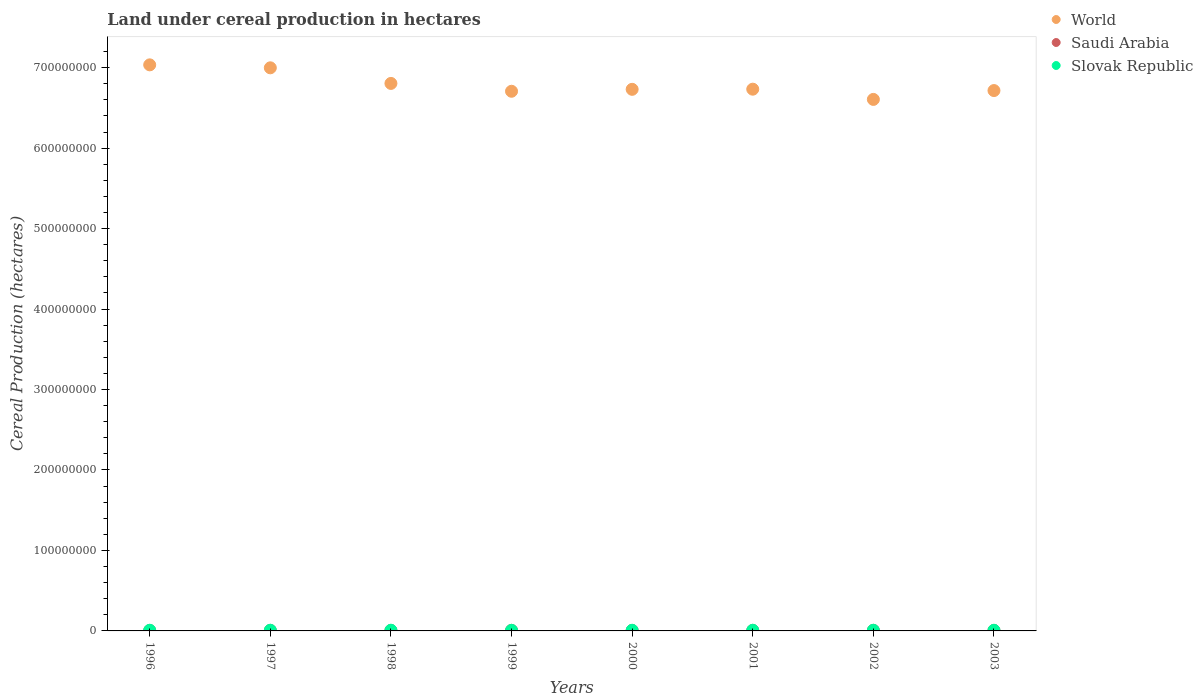Is the number of dotlines equal to the number of legend labels?
Ensure brevity in your answer.  Yes. What is the land under cereal production in World in 2003?
Give a very brief answer. 6.72e+08. Across all years, what is the maximum land under cereal production in Saudi Arabia?
Ensure brevity in your answer.  7.05e+05. Across all years, what is the minimum land under cereal production in Slovak Republic?
Your response must be concise. 7.34e+05. In which year was the land under cereal production in Slovak Republic minimum?
Provide a short and direct response. 1999. What is the total land under cereal production in Slovak Republic in the graph?
Make the answer very short. 6.54e+06. What is the difference between the land under cereal production in World in 2000 and that in 2003?
Offer a terse response. 1.53e+06. What is the difference between the land under cereal production in World in 2003 and the land under cereal production in Saudi Arabia in 1999?
Your answer should be very brief. 6.71e+08. What is the average land under cereal production in Saudi Arabia per year?
Provide a succinct answer. 6.51e+05. In the year 2001, what is the difference between the land under cereal production in World and land under cereal production in Slovak Republic?
Offer a very short reply. 6.72e+08. What is the ratio of the land under cereal production in Slovak Republic in 1996 to that in 1999?
Your response must be concise. 1.13. Is the land under cereal production in Slovak Republic in 1997 less than that in 2003?
Offer a terse response. No. Is the difference between the land under cereal production in World in 1998 and 2002 greater than the difference between the land under cereal production in Slovak Republic in 1998 and 2002?
Provide a short and direct response. Yes. What is the difference between the highest and the second highest land under cereal production in Saudi Arabia?
Provide a short and direct response. 7498. What is the difference between the highest and the lowest land under cereal production in Saudi Arabia?
Keep it short and to the point. 1.42e+05. In how many years, is the land under cereal production in Saudi Arabia greater than the average land under cereal production in Saudi Arabia taken over all years?
Provide a succinct answer. 5. Is the sum of the land under cereal production in Saudi Arabia in 1996 and 2000 greater than the maximum land under cereal production in World across all years?
Provide a succinct answer. No. Does the land under cereal production in Saudi Arabia monotonically increase over the years?
Provide a succinct answer. No. How many dotlines are there?
Your answer should be very brief. 3. How many years are there in the graph?
Ensure brevity in your answer.  8. What is the difference between two consecutive major ticks on the Y-axis?
Your answer should be very brief. 1.00e+08. Are the values on the major ticks of Y-axis written in scientific E-notation?
Give a very brief answer. No. Does the graph contain grids?
Offer a very short reply. No. How many legend labels are there?
Give a very brief answer. 3. What is the title of the graph?
Your answer should be very brief. Land under cereal production in hectares. Does "Peru" appear as one of the legend labels in the graph?
Offer a terse response. No. What is the label or title of the Y-axis?
Make the answer very short. Cereal Production (hectares). What is the Cereal Production (hectares) in World in 1996?
Provide a short and direct response. 7.03e+08. What is the Cereal Production (hectares) in Saudi Arabia in 1996?
Your response must be concise. 5.63e+05. What is the Cereal Production (hectares) in Slovak Republic in 1996?
Ensure brevity in your answer.  8.28e+05. What is the Cereal Production (hectares) of World in 1997?
Your answer should be compact. 7.00e+08. What is the Cereal Production (hectares) of Saudi Arabia in 1997?
Offer a terse response. 6.56e+05. What is the Cereal Production (hectares) of Slovak Republic in 1997?
Give a very brief answer. 8.50e+05. What is the Cereal Production (hectares) of World in 1998?
Ensure brevity in your answer.  6.80e+08. What is the Cereal Production (hectares) of Saudi Arabia in 1998?
Give a very brief answer. 6.22e+05. What is the Cereal Production (hectares) of Slovak Republic in 1998?
Keep it short and to the point. 8.60e+05. What is the Cereal Production (hectares) in World in 1999?
Provide a succinct answer. 6.71e+08. What is the Cereal Production (hectares) of Saudi Arabia in 1999?
Your answer should be compact. 6.86e+05. What is the Cereal Production (hectares) of Slovak Republic in 1999?
Your response must be concise. 7.34e+05. What is the Cereal Production (hectares) of World in 2000?
Provide a short and direct response. 6.73e+08. What is the Cereal Production (hectares) of Saudi Arabia in 2000?
Give a very brief answer. 6.16e+05. What is the Cereal Production (hectares) in Slovak Republic in 2000?
Your response must be concise. 8.13e+05. What is the Cereal Production (hectares) of World in 2001?
Your answer should be very brief. 6.73e+08. What is the Cereal Production (hectares) of Saudi Arabia in 2001?
Make the answer very short. 6.59e+05. What is the Cereal Production (hectares) in Slovak Republic in 2001?
Offer a very short reply. 8.35e+05. What is the Cereal Production (hectares) of World in 2002?
Give a very brief answer. 6.61e+08. What is the Cereal Production (hectares) in Saudi Arabia in 2002?
Make the answer very short. 7.05e+05. What is the Cereal Production (hectares) in Slovak Republic in 2002?
Provide a short and direct response. 8.20e+05. What is the Cereal Production (hectares) of World in 2003?
Your response must be concise. 6.72e+08. What is the Cereal Production (hectares) in Saudi Arabia in 2003?
Your answer should be compact. 6.97e+05. What is the Cereal Production (hectares) in Slovak Republic in 2003?
Your answer should be very brief. 7.95e+05. Across all years, what is the maximum Cereal Production (hectares) in World?
Offer a very short reply. 7.03e+08. Across all years, what is the maximum Cereal Production (hectares) in Saudi Arabia?
Offer a terse response. 7.05e+05. Across all years, what is the maximum Cereal Production (hectares) of Slovak Republic?
Ensure brevity in your answer.  8.60e+05. Across all years, what is the minimum Cereal Production (hectares) of World?
Your response must be concise. 6.61e+08. Across all years, what is the minimum Cereal Production (hectares) of Saudi Arabia?
Provide a succinct answer. 5.63e+05. Across all years, what is the minimum Cereal Production (hectares) of Slovak Republic?
Your answer should be very brief. 7.34e+05. What is the total Cereal Production (hectares) in World in the graph?
Your answer should be very brief. 5.43e+09. What is the total Cereal Production (hectares) of Saudi Arabia in the graph?
Provide a succinct answer. 5.21e+06. What is the total Cereal Production (hectares) in Slovak Republic in the graph?
Make the answer very short. 6.54e+06. What is the difference between the Cereal Production (hectares) in World in 1996 and that in 1997?
Provide a succinct answer. 3.68e+06. What is the difference between the Cereal Production (hectares) of Saudi Arabia in 1996 and that in 1997?
Ensure brevity in your answer.  -9.32e+04. What is the difference between the Cereal Production (hectares) in Slovak Republic in 1996 and that in 1997?
Give a very brief answer. -2.26e+04. What is the difference between the Cereal Production (hectares) in World in 1996 and that in 1998?
Give a very brief answer. 2.31e+07. What is the difference between the Cereal Production (hectares) of Saudi Arabia in 1996 and that in 1998?
Give a very brief answer. -5.86e+04. What is the difference between the Cereal Production (hectares) of Slovak Republic in 1996 and that in 1998?
Ensure brevity in your answer.  -3.20e+04. What is the difference between the Cereal Production (hectares) in World in 1996 and that in 1999?
Offer a terse response. 3.28e+07. What is the difference between the Cereal Production (hectares) of Saudi Arabia in 1996 and that in 1999?
Your response must be concise. -1.23e+05. What is the difference between the Cereal Production (hectares) of Slovak Republic in 1996 and that in 1999?
Offer a terse response. 9.40e+04. What is the difference between the Cereal Production (hectares) in World in 1996 and that in 2000?
Keep it short and to the point. 3.04e+07. What is the difference between the Cereal Production (hectares) in Saudi Arabia in 1996 and that in 2000?
Give a very brief answer. -5.32e+04. What is the difference between the Cereal Production (hectares) of Slovak Republic in 1996 and that in 2000?
Give a very brief answer. 1.44e+04. What is the difference between the Cereal Production (hectares) in World in 1996 and that in 2001?
Provide a succinct answer. 3.02e+07. What is the difference between the Cereal Production (hectares) in Saudi Arabia in 1996 and that in 2001?
Provide a succinct answer. -9.59e+04. What is the difference between the Cereal Production (hectares) in Slovak Republic in 1996 and that in 2001?
Provide a succinct answer. -7431. What is the difference between the Cereal Production (hectares) of World in 1996 and that in 2002?
Offer a terse response. 4.29e+07. What is the difference between the Cereal Production (hectares) in Saudi Arabia in 1996 and that in 2002?
Your answer should be compact. -1.42e+05. What is the difference between the Cereal Production (hectares) in Slovak Republic in 1996 and that in 2002?
Your answer should be compact. 7393. What is the difference between the Cereal Production (hectares) in World in 1996 and that in 2003?
Your response must be concise. 3.19e+07. What is the difference between the Cereal Production (hectares) in Saudi Arabia in 1996 and that in 2003?
Give a very brief answer. -1.34e+05. What is the difference between the Cereal Production (hectares) in Slovak Republic in 1996 and that in 2003?
Keep it short and to the point. 3.33e+04. What is the difference between the Cereal Production (hectares) of World in 1997 and that in 1998?
Provide a succinct answer. 1.94e+07. What is the difference between the Cereal Production (hectares) in Saudi Arabia in 1997 and that in 1998?
Offer a terse response. 3.46e+04. What is the difference between the Cereal Production (hectares) of Slovak Republic in 1997 and that in 1998?
Make the answer very short. -9363. What is the difference between the Cereal Production (hectares) of World in 1997 and that in 1999?
Your answer should be compact. 2.91e+07. What is the difference between the Cereal Production (hectares) of Saudi Arabia in 1997 and that in 1999?
Your answer should be very brief. -3.00e+04. What is the difference between the Cereal Production (hectares) of Slovak Republic in 1997 and that in 1999?
Offer a very short reply. 1.17e+05. What is the difference between the Cereal Production (hectares) of World in 1997 and that in 2000?
Provide a succinct answer. 2.67e+07. What is the difference between the Cereal Production (hectares) of Saudi Arabia in 1997 and that in 2000?
Offer a very short reply. 4.00e+04. What is the difference between the Cereal Production (hectares) in Slovak Republic in 1997 and that in 2000?
Your answer should be very brief. 3.70e+04. What is the difference between the Cereal Production (hectares) of World in 1997 and that in 2001?
Your answer should be compact. 2.66e+07. What is the difference between the Cereal Production (hectares) of Saudi Arabia in 1997 and that in 2001?
Your response must be concise. -2737. What is the difference between the Cereal Production (hectares) in Slovak Republic in 1997 and that in 2001?
Your answer should be compact. 1.52e+04. What is the difference between the Cereal Production (hectares) of World in 1997 and that in 2002?
Give a very brief answer. 3.93e+07. What is the difference between the Cereal Production (hectares) in Saudi Arabia in 1997 and that in 2002?
Your response must be concise. -4.84e+04. What is the difference between the Cereal Production (hectares) of Slovak Republic in 1997 and that in 2002?
Offer a very short reply. 3.00e+04. What is the difference between the Cereal Production (hectares) of World in 1997 and that in 2003?
Your answer should be very brief. 2.83e+07. What is the difference between the Cereal Production (hectares) of Saudi Arabia in 1997 and that in 2003?
Give a very brief answer. -4.09e+04. What is the difference between the Cereal Production (hectares) in Slovak Republic in 1997 and that in 2003?
Make the answer very short. 5.59e+04. What is the difference between the Cereal Production (hectares) in World in 1998 and that in 1999?
Your answer should be very brief. 9.75e+06. What is the difference between the Cereal Production (hectares) of Saudi Arabia in 1998 and that in 1999?
Your answer should be compact. -6.45e+04. What is the difference between the Cereal Production (hectares) of Slovak Republic in 1998 and that in 1999?
Keep it short and to the point. 1.26e+05. What is the difference between the Cereal Production (hectares) in World in 1998 and that in 2000?
Offer a very short reply. 7.34e+06. What is the difference between the Cereal Production (hectares) of Saudi Arabia in 1998 and that in 2000?
Your answer should be very brief. 5457. What is the difference between the Cereal Production (hectares) of Slovak Republic in 1998 and that in 2000?
Ensure brevity in your answer.  4.64e+04. What is the difference between the Cereal Production (hectares) of World in 1998 and that in 2001?
Make the answer very short. 7.16e+06. What is the difference between the Cereal Production (hectares) in Saudi Arabia in 1998 and that in 2001?
Provide a short and direct response. -3.73e+04. What is the difference between the Cereal Production (hectares) in Slovak Republic in 1998 and that in 2001?
Keep it short and to the point. 2.46e+04. What is the difference between the Cereal Production (hectares) in World in 1998 and that in 2002?
Provide a short and direct response. 1.99e+07. What is the difference between the Cereal Production (hectares) of Saudi Arabia in 1998 and that in 2002?
Offer a very short reply. -8.30e+04. What is the difference between the Cereal Production (hectares) of Slovak Republic in 1998 and that in 2002?
Keep it short and to the point. 3.94e+04. What is the difference between the Cereal Production (hectares) in World in 1998 and that in 2003?
Ensure brevity in your answer.  8.87e+06. What is the difference between the Cereal Production (hectares) in Saudi Arabia in 1998 and that in 2003?
Ensure brevity in your answer.  -7.55e+04. What is the difference between the Cereal Production (hectares) of Slovak Republic in 1998 and that in 2003?
Ensure brevity in your answer.  6.53e+04. What is the difference between the Cereal Production (hectares) in World in 1999 and that in 2000?
Give a very brief answer. -2.40e+06. What is the difference between the Cereal Production (hectares) of Saudi Arabia in 1999 and that in 2000?
Provide a short and direct response. 7.00e+04. What is the difference between the Cereal Production (hectares) in Slovak Republic in 1999 and that in 2000?
Make the answer very short. -7.96e+04. What is the difference between the Cereal Production (hectares) of World in 1999 and that in 2001?
Make the answer very short. -2.59e+06. What is the difference between the Cereal Production (hectares) in Saudi Arabia in 1999 and that in 2001?
Your response must be concise. 2.73e+04. What is the difference between the Cereal Production (hectares) in Slovak Republic in 1999 and that in 2001?
Offer a very short reply. -1.01e+05. What is the difference between the Cereal Production (hectares) of World in 1999 and that in 2002?
Offer a very short reply. 1.01e+07. What is the difference between the Cereal Production (hectares) in Saudi Arabia in 1999 and that in 2002?
Give a very brief answer. -1.84e+04. What is the difference between the Cereal Production (hectares) of Slovak Republic in 1999 and that in 2002?
Provide a succinct answer. -8.66e+04. What is the difference between the Cereal Production (hectares) in World in 1999 and that in 2003?
Ensure brevity in your answer.  -8.71e+05. What is the difference between the Cereal Production (hectares) of Saudi Arabia in 1999 and that in 2003?
Your response must be concise. -1.09e+04. What is the difference between the Cereal Production (hectares) in Slovak Republic in 1999 and that in 2003?
Offer a very short reply. -6.07e+04. What is the difference between the Cereal Production (hectares) in World in 2000 and that in 2001?
Give a very brief answer. -1.80e+05. What is the difference between the Cereal Production (hectares) of Saudi Arabia in 2000 and that in 2001?
Offer a terse response. -4.27e+04. What is the difference between the Cereal Production (hectares) in Slovak Republic in 2000 and that in 2001?
Provide a succinct answer. -2.18e+04. What is the difference between the Cereal Production (hectares) of World in 2000 and that in 2002?
Your answer should be compact. 1.25e+07. What is the difference between the Cereal Production (hectares) in Saudi Arabia in 2000 and that in 2002?
Keep it short and to the point. -8.84e+04. What is the difference between the Cereal Production (hectares) in Slovak Republic in 2000 and that in 2002?
Keep it short and to the point. -6992. What is the difference between the Cereal Production (hectares) in World in 2000 and that in 2003?
Give a very brief answer. 1.53e+06. What is the difference between the Cereal Production (hectares) of Saudi Arabia in 2000 and that in 2003?
Your answer should be compact. -8.09e+04. What is the difference between the Cereal Production (hectares) in Slovak Republic in 2000 and that in 2003?
Provide a succinct answer. 1.89e+04. What is the difference between the Cereal Production (hectares) of World in 2001 and that in 2002?
Your answer should be very brief. 1.27e+07. What is the difference between the Cereal Production (hectares) in Saudi Arabia in 2001 and that in 2002?
Offer a very short reply. -4.57e+04. What is the difference between the Cereal Production (hectares) in Slovak Republic in 2001 and that in 2002?
Provide a short and direct response. 1.48e+04. What is the difference between the Cereal Production (hectares) of World in 2001 and that in 2003?
Your answer should be very brief. 1.71e+06. What is the difference between the Cereal Production (hectares) of Saudi Arabia in 2001 and that in 2003?
Offer a very short reply. -3.82e+04. What is the difference between the Cereal Production (hectares) in Slovak Republic in 2001 and that in 2003?
Make the answer very short. 4.07e+04. What is the difference between the Cereal Production (hectares) of World in 2002 and that in 2003?
Your response must be concise. -1.10e+07. What is the difference between the Cereal Production (hectares) in Saudi Arabia in 2002 and that in 2003?
Your answer should be compact. 7498. What is the difference between the Cereal Production (hectares) in Slovak Republic in 2002 and that in 2003?
Make the answer very short. 2.59e+04. What is the difference between the Cereal Production (hectares) in World in 1996 and the Cereal Production (hectares) in Saudi Arabia in 1997?
Ensure brevity in your answer.  7.03e+08. What is the difference between the Cereal Production (hectares) in World in 1996 and the Cereal Production (hectares) in Slovak Republic in 1997?
Give a very brief answer. 7.03e+08. What is the difference between the Cereal Production (hectares) of Saudi Arabia in 1996 and the Cereal Production (hectares) of Slovak Republic in 1997?
Provide a short and direct response. -2.87e+05. What is the difference between the Cereal Production (hectares) in World in 1996 and the Cereal Production (hectares) in Saudi Arabia in 1998?
Ensure brevity in your answer.  7.03e+08. What is the difference between the Cereal Production (hectares) in World in 1996 and the Cereal Production (hectares) in Slovak Republic in 1998?
Give a very brief answer. 7.03e+08. What is the difference between the Cereal Production (hectares) in Saudi Arabia in 1996 and the Cereal Production (hectares) in Slovak Republic in 1998?
Your answer should be very brief. -2.97e+05. What is the difference between the Cereal Production (hectares) of World in 1996 and the Cereal Production (hectares) of Saudi Arabia in 1999?
Your answer should be compact. 7.03e+08. What is the difference between the Cereal Production (hectares) of World in 1996 and the Cereal Production (hectares) of Slovak Republic in 1999?
Make the answer very short. 7.03e+08. What is the difference between the Cereal Production (hectares) of Saudi Arabia in 1996 and the Cereal Production (hectares) of Slovak Republic in 1999?
Your answer should be very brief. -1.71e+05. What is the difference between the Cereal Production (hectares) in World in 1996 and the Cereal Production (hectares) in Saudi Arabia in 2000?
Give a very brief answer. 7.03e+08. What is the difference between the Cereal Production (hectares) in World in 1996 and the Cereal Production (hectares) in Slovak Republic in 2000?
Make the answer very short. 7.03e+08. What is the difference between the Cereal Production (hectares) of Saudi Arabia in 1996 and the Cereal Production (hectares) of Slovak Republic in 2000?
Make the answer very short. -2.50e+05. What is the difference between the Cereal Production (hectares) in World in 1996 and the Cereal Production (hectares) in Saudi Arabia in 2001?
Offer a very short reply. 7.03e+08. What is the difference between the Cereal Production (hectares) in World in 1996 and the Cereal Production (hectares) in Slovak Republic in 2001?
Your answer should be compact. 7.03e+08. What is the difference between the Cereal Production (hectares) in Saudi Arabia in 1996 and the Cereal Production (hectares) in Slovak Republic in 2001?
Your response must be concise. -2.72e+05. What is the difference between the Cereal Production (hectares) in World in 1996 and the Cereal Production (hectares) in Saudi Arabia in 2002?
Make the answer very short. 7.03e+08. What is the difference between the Cereal Production (hectares) in World in 1996 and the Cereal Production (hectares) in Slovak Republic in 2002?
Provide a short and direct response. 7.03e+08. What is the difference between the Cereal Production (hectares) of Saudi Arabia in 1996 and the Cereal Production (hectares) of Slovak Republic in 2002?
Your response must be concise. -2.57e+05. What is the difference between the Cereal Production (hectares) of World in 1996 and the Cereal Production (hectares) of Saudi Arabia in 2003?
Provide a succinct answer. 7.03e+08. What is the difference between the Cereal Production (hectares) of World in 1996 and the Cereal Production (hectares) of Slovak Republic in 2003?
Your response must be concise. 7.03e+08. What is the difference between the Cereal Production (hectares) in Saudi Arabia in 1996 and the Cereal Production (hectares) in Slovak Republic in 2003?
Offer a terse response. -2.31e+05. What is the difference between the Cereal Production (hectares) in World in 1997 and the Cereal Production (hectares) in Saudi Arabia in 1998?
Your answer should be very brief. 6.99e+08. What is the difference between the Cereal Production (hectares) of World in 1997 and the Cereal Production (hectares) of Slovak Republic in 1998?
Offer a very short reply. 6.99e+08. What is the difference between the Cereal Production (hectares) of Saudi Arabia in 1997 and the Cereal Production (hectares) of Slovak Republic in 1998?
Provide a short and direct response. -2.03e+05. What is the difference between the Cereal Production (hectares) of World in 1997 and the Cereal Production (hectares) of Saudi Arabia in 1999?
Give a very brief answer. 6.99e+08. What is the difference between the Cereal Production (hectares) of World in 1997 and the Cereal Production (hectares) of Slovak Republic in 1999?
Give a very brief answer. 6.99e+08. What is the difference between the Cereal Production (hectares) of Saudi Arabia in 1997 and the Cereal Production (hectares) of Slovak Republic in 1999?
Offer a very short reply. -7.75e+04. What is the difference between the Cereal Production (hectares) of World in 1997 and the Cereal Production (hectares) of Saudi Arabia in 2000?
Ensure brevity in your answer.  6.99e+08. What is the difference between the Cereal Production (hectares) in World in 1997 and the Cereal Production (hectares) in Slovak Republic in 2000?
Your answer should be compact. 6.99e+08. What is the difference between the Cereal Production (hectares) of Saudi Arabia in 1997 and the Cereal Production (hectares) of Slovak Republic in 2000?
Give a very brief answer. -1.57e+05. What is the difference between the Cereal Production (hectares) of World in 1997 and the Cereal Production (hectares) of Saudi Arabia in 2001?
Offer a terse response. 6.99e+08. What is the difference between the Cereal Production (hectares) in World in 1997 and the Cereal Production (hectares) in Slovak Republic in 2001?
Your response must be concise. 6.99e+08. What is the difference between the Cereal Production (hectares) in Saudi Arabia in 1997 and the Cereal Production (hectares) in Slovak Republic in 2001?
Offer a terse response. -1.79e+05. What is the difference between the Cereal Production (hectares) of World in 1997 and the Cereal Production (hectares) of Saudi Arabia in 2002?
Make the answer very short. 6.99e+08. What is the difference between the Cereal Production (hectares) of World in 1997 and the Cereal Production (hectares) of Slovak Republic in 2002?
Provide a succinct answer. 6.99e+08. What is the difference between the Cereal Production (hectares) in Saudi Arabia in 1997 and the Cereal Production (hectares) in Slovak Republic in 2002?
Your response must be concise. -1.64e+05. What is the difference between the Cereal Production (hectares) of World in 1997 and the Cereal Production (hectares) of Saudi Arabia in 2003?
Offer a very short reply. 6.99e+08. What is the difference between the Cereal Production (hectares) of World in 1997 and the Cereal Production (hectares) of Slovak Republic in 2003?
Give a very brief answer. 6.99e+08. What is the difference between the Cereal Production (hectares) of Saudi Arabia in 1997 and the Cereal Production (hectares) of Slovak Republic in 2003?
Your response must be concise. -1.38e+05. What is the difference between the Cereal Production (hectares) of World in 1998 and the Cereal Production (hectares) of Saudi Arabia in 1999?
Ensure brevity in your answer.  6.80e+08. What is the difference between the Cereal Production (hectares) of World in 1998 and the Cereal Production (hectares) of Slovak Republic in 1999?
Ensure brevity in your answer.  6.80e+08. What is the difference between the Cereal Production (hectares) of Saudi Arabia in 1998 and the Cereal Production (hectares) of Slovak Republic in 1999?
Ensure brevity in your answer.  -1.12e+05. What is the difference between the Cereal Production (hectares) of World in 1998 and the Cereal Production (hectares) of Saudi Arabia in 2000?
Your answer should be very brief. 6.80e+08. What is the difference between the Cereal Production (hectares) in World in 1998 and the Cereal Production (hectares) in Slovak Republic in 2000?
Provide a short and direct response. 6.80e+08. What is the difference between the Cereal Production (hectares) in Saudi Arabia in 1998 and the Cereal Production (hectares) in Slovak Republic in 2000?
Your answer should be very brief. -1.92e+05. What is the difference between the Cereal Production (hectares) in World in 1998 and the Cereal Production (hectares) in Saudi Arabia in 2001?
Provide a succinct answer. 6.80e+08. What is the difference between the Cereal Production (hectares) in World in 1998 and the Cereal Production (hectares) in Slovak Republic in 2001?
Your response must be concise. 6.80e+08. What is the difference between the Cereal Production (hectares) of Saudi Arabia in 1998 and the Cereal Production (hectares) of Slovak Republic in 2001?
Provide a short and direct response. -2.13e+05. What is the difference between the Cereal Production (hectares) in World in 1998 and the Cereal Production (hectares) in Saudi Arabia in 2002?
Your answer should be very brief. 6.80e+08. What is the difference between the Cereal Production (hectares) in World in 1998 and the Cereal Production (hectares) in Slovak Republic in 2002?
Make the answer very short. 6.80e+08. What is the difference between the Cereal Production (hectares) of Saudi Arabia in 1998 and the Cereal Production (hectares) of Slovak Republic in 2002?
Offer a very short reply. -1.99e+05. What is the difference between the Cereal Production (hectares) in World in 1998 and the Cereal Production (hectares) in Saudi Arabia in 2003?
Provide a short and direct response. 6.80e+08. What is the difference between the Cereal Production (hectares) of World in 1998 and the Cereal Production (hectares) of Slovak Republic in 2003?
Offer a very short reply. 6.80e+08. What is the difference between the Cereal Production (hectares) of Saudi Arabia in 1998 and the Cereal Production (hectares) of Slovak Republic in 2003?
Give a very brief answer. -1.73e+05. What is the difference between the Cereal Production (hectares) of World in 1999 and the Cereal Production (hectares) of Saudi Arabia in 2000?
Your answer should be very brief. 6.70e+08. What is the difference between the Cereal Production (hectares) of World in 1999 and the Cereal Production (hectares) of Slovak Republic in 2000?
Give a very brief answer. 6.70e+08. What is the difference between the Cereal Production (hectares) of Saudi Arabia in 1999 and the Cereal Production (hectares) of Slovak Republic in 2000?
Offer a terse response. -1.27e+05. What is the difference between the Cereal Production (hectares) in World in 1999 and the Cereal Production (hectares) in Saudi Arabia in 2001?
Provide a succinct answer. 6.70e+08. What is the difference between the Cereal Production (hectares) in World in 1999 and the Cereal Production (hectares) in Slovak Republic in 2001?
Offer a terse response. 6.70e+08. What is the difference between the Cereal Production (hectares) of Saudi Arabia in 1999 and the Cereal Production (hectares) of Slovak Republic in 2001?
Provide a succinct answer. -1.49e+05. What is the difference between the Cereal Production (hectares) in World in 1999 and the Cereal Production (hectares) in Saudi Arabia in 2002?
Provide a succinct answer. 6.70e+08. What is the difference between the Cereal Production (hectares) of World in 1999 and the Cereal Production (hectares) of Slovak Republic in 2002?
Ensure brevity in your answer.  6.70e+08. What is the difference between the Cereal Production (hectares) in Saudi Arabia in 1999 and the Cereal Production (hectares) in Slovak Republic in 2002?
Your answer should be very brief. -1.34e+05. What is the difference between the Cereal Production (hectares) of World in 1999 and the Cereal Production (hectares) of Saudi Arabia in 2003?
Give a very brief answer. 6.70e+08. What is the difference between the Cereal Production (hectares) in World in 1999 and the Cereal Production (hectares) in Slovak Republic in 2003?
Offer a very short reply. 6.70e+08. What is the difference between the Cereal Production (hectares) in Saudi Arabia in 1999 and the Cereal Production (hectares) in Slovak Republic in 2003?
Give a very brief answer. -1.08e+05. What is the difference between the Cereal Production (hectares) of World in 2000 and the Cereal Production (hectares) of Saudi Arabia in 2001?
Provide a short and direct response. 6.72e+08. What is the difference between the Cereal Production (hectares) in World in 2000 and the Cereal Production (hectares) in Slovak Republic in 2001?
Your answer should be very brief. 6.72e+08. What is the difference between the Cereal Production (hectares) of Saudi Arabia in 2000 and the Cereal Production (hectares) of Slovak Republic in 2001?
Offer a terse response. -2.19e+05. What is the difference between the Cereal Production (hectares) of World in 2000 and the Cereal Production (hectares) of Saudi Arabia in 2002?
Keep it short and to the point. 6.72e+08. What is the difference between the Cereal Production (hectares) in World in 2000 and the Cereal Production (hectares) in Slovak Republic in 2002?
Provide a succinct answer. 6.72e+08. What is the difference between the Cereal Production (hectares) in Saudi Arabia in 2000 and the Cereal Production (hectares) in Slovak Republic in 2002?
Offer a terse response. -2.04e+05. What is the difference between the Cereal Production (hectares) of World in 2000 and the Cereal Production (hectares) of Saudi Arabia in 2003?
Make the answer very short. 6.72e+08. What is the difference between the Cereal Production (hectares) in World in 2000 and the Cereal Production (hectares) in Slovak Republic in 2003?
Your response must be concise. 6.72e+08. What is the difference between the Cereal Production (hectares) in Saudi Arabia in 2000 and the Cereal Production (hectares) in Slovak Republic in 2003?
Keep it short and to the point. -1.78e+05. What is the difference between the Cereal Production (hectares) of World in 2001 and the Cereal Production (hectares) of Saudi Arabia in 2002?
Make the answer very short. 6.73e+08. What is the difference between the Cereal Production (hectares) in World in 2001 and the Cereal Production (hectares) in Slovak Republic in 2002?
Provide a succinct answer. 6.72e+08. What is the difference between the Cereal Production (hectares) in Saudi Arabia in 2001 and the Cereal Production (hectares) in Slovak Republic in 2002?
Your answer should be very brief. -1.61e+05. What is the difference between the Cereal Production (hectares) in World in 2001 and the Cereal Production (hectares) in Saudi Arabia in 2003?
Provide a succinct answer. 6.73e+08. What is the difference between the Cereal Production (hectares) of World in 2001 and the Cereal Production (hectares) of Slovak Republic in 2003?
Ensure brevity in your answer.  6.72e+08. What is the difference between the Cereal Production (hectares) in Saudi Arabia in 2001 and the Cereal Production (hectares) in Slovak Republic in 2003?
Your answer should be compact. -1.35e+05. What is the difference between the Cereal Production (hectares) in World in 2002 and the Cereal Production (hectares) in Saudi Arabia in 2003?
Your answer should be compact. 6.60e+08. What is the difference between the Cereal Production (hectares) of World in 2002 and the Cereal Production (hectares) of Slovak Republic in 2003?
Make the answer very short. 6.60e+08. What is the difference between the Cereal Production (hectares) of Saudi Arabia in 2002 and the Cereal Production (hectares) of Slovak Republic in 2003?
Your response must be concise. -8.97e+04. What is the average Cereal Production (hectares) of World per year?
Offer a very short reply. 6.79e+08. What is the average Cereal Production (hectares) of Saudi Arabia per year?
Your response must be concise. 6.51e+05. What is the average Cereal Production (hectares) of Slovak Republic per year?
Offer a terse response. 8.17e+05. In the year 1996, what is the difference between the Cereal Production (hectares) in World and Cereal Production (hectares) in Saudi Arabia?
Ensure brevity in your answer.  7.03e+08. In the year 1996, what is the difference between the Cereal Production (hectares) of World and Cereal Production (hectares) of Slovak Republic?
Your answer should be compact. 7.03e+08. In the year 1996, what is the difference between the Cereal Production (hectares) of Saudi Arabia and Cereal Production (hectares) of Slovak Republic?
Your answer should be compact. -2.65e+05. In the year 1997, what is the difference between the Cereal Production (hectares) of World and Cereal Production (hectares) of Saudi Arabia?
Provide a short and direct response. 6.99e+08. In the year 1997, what is the difference between the Cereal Production (hectares) in World and Cereal Production (hectares) in Slovak Republic?
Ensure brevity in your answer.  6.99e+08. In the year 1997, what is the difference between the Cereal Production (hectares) in Saudi Arabia and Cereal Production (hectares) in Slovak Republic?
Provide a succinct answer. -1.94e+05. In the year 1998, what is the difference between the Cereal Production (hectares) in World and Cereal Production (hectares) in Saudi Arabia?
Your response must be concise. 6.80e+08. In the year 1998, what is the difference between the Cereal Production (hectares) of World and Cereal Production (hectares) of Slovak Republic?
Offer a very short reply. 6.80e+08. In the year 1998, what is the difference between the Cereal Production (hectares) in Saudi Arabia and Cereal Production (hectares) in Slovak Republic?
Offer a terse response. -2.38e+05. In the year 1999, what is the difference between the Cereal Production (hectares) in World and Cereal Production (hectares) in Saudi Arabia?
Your answer should be compact. 6.70e+08. In the year 1999, what is the difference between the Cereal Production (hectares) of World and Cereal Production (hectares) of Slovak Republic?
Provide a succinct answer. 6.70e+08. In the year 1999, what is the difference between the Cereal Production (hectares) of Saudi Arabia and Cereal Production (hectares) of Slovak Republic?
Offer a very short reply. -4.75e+04. In the year 2000, what is the difference between the Cereal Production (hectares) of World and Cereal Production (hectares) of Saudi Arabia?
Your response must be concise. 6.72e+08. In the year 2000, what is the difference between the Cereal Production (hectares) in World and Cereal Production (hectares) in Slovak Republic?
Keep it short and to the point. 6.72e+08. In the year 2000, what is the difference between the Cereal Production (hectares) of Saudi Arabia and Cereal Production (hectares) of Slovak Republic?
Ensure brevity in your answer.  -1.97e+05. In the year 2001, what is the difference between the Cereal Production (hectares) in World and Cereal Production (hectares) in Saudi Arabia?
Ensure brevity in your answer.  6.73e+08. In the year 2001, what is the difference between the Cereal Production (hectares) in World and Cereal Production (hectares) in Slovak Republic?
Your answer should be compact. 6.72e+08. In the year 2001, what is the difference between the Cereal Production (hectares) in Saudi Arabia and Cereal Production (hectares) in Slovak Republic?
Your response must be concise. -1.76e+05. In the year 2002, what is the difference between the Cereal Production (hectares) in World and Cereal Production (hectares) in Saudi Arabia?
Offer a terse response. 6.60e+08. In the year 2002, what is the difference between the Cereal Production (hectares) in World and Cereal Production (hectares) in Slovak Republic?
Provide a short and direct response. 6.60e+08. In the year 2002, what is the difference between the Cereal Production (hectares) of Saudi Arabia and Cereal Production (hectares) of Slovak Republic?
Offer a terse response. -1.16e+05. In the year 2003, what is the difference between the Cereal Production (hectares) in World and Cereal Production (hectares) in Saudi Arabia?
Your response must be concise. 6.71e+08. In the year 2003, what is the difference between the Cereal Production (hectares) in World and Cereal Production (hectares) in Slovak Republic?
Provide a succinct answer. 6.71e+08. In the year 2003, what is the difference between the Cereal Production (hectares) in Saudi Arabia and Cereal Production (hectares) in Slovak Republic?
Provide a short and direct response. -9.72e+04. What is the ratio of the Cereal Production (hectares) in World in 1996 to that in 1997?
Your answer should be compact. 1.01. What is the ratio of the Cereal Production (hectares) of Saudi Arabia in 1996 to that in 1997?
Keep it short and to the point. 0.86. What is the ratio of the Cereal Production (hectares) in Slovak Republic in 1996 to that in 1997?
Ensure brevity in your answer.  0.97. What is the ratio of the Cereal Production (hectares) of World in 1996 to that in 1998?
Offer a terse response. 1.03. What is the ratio of the Cereal Production (hectares) of Saudi Arabia in 1996 to that in 1998?
Offer a very short reply. 0.91. What is the ratio of the Cereal Production (hectares) in Slovak Republic in 1996 to that in 1998?
Provide a short and direct response. 0.96. What is the ratio of the Cereal Production (hectares) in World in 1996 to that in 1999?
Offer a terse response. 1.05. What is the ratio of the Cereal Production (hectares) in Saudi Arabia in 1996 to that in 1999?
Provide a short and direct response. 0.82. What is the ratio of the Cereal Production (hectares) in Slovak Republic in 1996 to that in 1999?
Your answer should be very brief. 1.13. What is the ratio of the Cereal Production (hectares) of World in 1996 to that in 2000?
Ensure brevity in your answer.  1.05. What is the ratio of the Cereal Production (hectares) in Saudi Arabia in 1996 to that in 2000?
Your answer should be very brief. 0.91. What is the ratio of the Cereal Production (hectares) of Slovak Republic in 1996 to that in 2000?
Give a very brief answer. 1.02. What is the ratio of the Cereal Production (hectares) of World in 1996 to that in 2001?
Make the answer very short. 1.04. What is the ratio of the Cereal Production (hectares) of Saudi Arabia in 1996 to that in 2001?
Provide a succinct answer. 0.85. What is the ratio of the Cereal Production (hectares) in World in 1996 to that in 2002?
Your response must be concise. 1.06. What is the ratio of the Cereal Production (hectares) in Saudi Arabia in 1996 to that in 2002?
Offer a very short reply. 0.8. What is the ratio of the Cereal Production (hectares) in World in 1996 to that in 2003?
Ensure brevity in your answer.  1.05. What is the ratio of the Cereal Production (hectares) of Saudi Arabia in 1996 to that in 2003?
Give a very brief answer. 0.81. What is the ratio of the Cereal Production (hectares) in Slovak Republic in 1996 to that in 2003?
Provide a short and direct response. 1.04. What is the ratio of the Cereal Production (hectares) in World in 1997 to that in 1998?
Your answer should be very brief. 1.03. What is the ratio of the Cereal Production (hectares) of Saudi Arabia in 1997 to that in 1998?
Your answer should be very brief. 1.06. What is the ratio of the Cereal Production (hectares) in Slovak Republic in 1997 to that in 1998?
Offer a very short reply. 0.99. What is the ratio of the Cereal Production (hectares) of World in 1997 to that in 1999?
Offer a terse response. 1.04. What is the ratio of the Cereal Production (hectares) of Saudi Arabia in 1997 to that in 1999?
Offer a very short reply. 0.96. What is the ratio of the Cereal Production (hectares) of Slovak Republic in 1997 to that in 1999?
Provide a succinct answer. 1.16. What is the ratio of the Cereal Production (hectares) in World in 1997 to that in 2000?
Offer a terse response. 1.04. What is the ratio of the Cereal Production (hectares) of Saudi Arabia in 1997 to that in 2000?
Your response must be concise. 1.06. What is the ratio of the Cereal Production (hectares) in Slovak Republic in 1997 to that in 2000?
Offer a very short reply. 1.05. What is the ratio of the Cereal Production (hectares) of World in 1997 to that in 2001?
Keep it short and to the point. 1.04. What is the ratio of the Cereal Production (hectares) in Slovak Republic in 1997 to that in 2001?
Keep it short and to the point. 1.02. What is the ratio of the Cereal Production (hectares) of World in 1997 to that in 2002?
Provide a succinct answer. 1.06. What is the ratio of the Cereal Production (hectares) of Saudi Arabia in 1997 to that in 2002?
Ensure brevity in your answer.  0.93. What is the ratio of the Cereal Production (hectares) in Slovak Republic in 1997 to that in 2002?
Your response must be concise. 1.04. What is the ratio of the Cereal Production (hectares) of World in 1997 to that in 2003?
Offer a very short reply. 1.04. What is the ratio of the Cereal Production (hectares) of Saudi Arabia in 1997 to that in 2003?
Provide a short and direct response. 0.94. What is the ratio of the Cereal Production (hectares) in Slovak Republic in 1997 to that in 2003?
Your answer should be compact. 1.07. What is the ratio of the Cereal Production (hectares) of World in 1998 to that in 1999?
Provide a succinct answer. 1.01. What is the ratio of the Cereal Production (hectares) in Saudi Arabia in 1998 to that in 1999?
Keep it short and to the point. 0.91. What is the ratio of the Cereal Production (hectares) of Slovak Republic in 1998 to that in 1999?
Keep it short and to the point. 1.17. What is the ratio of the Cereal Production (hectares) of World in 1998 to that in 2000?
Offer a terse response. 1.01. What is the ratio of the Cereal Production (hectares) in Saudi Arabia in 1998 to that in 2000?
Ensure brevity in your answer.  1.01. What is the ratio of the Cereal Production (hectares) of Slovak Republic in 1998 to that in 2000?
Your answer should be very brief. 1.06. What is the ratio of the Cereal Production (hectares) of World in 1998 to that in 2001?
Offer a terse response. 1.01. What is the ratio of the Cereal Production (hectares) in Saudi Arabia in 1998 to that in 2001?
Keep it short and to the point. 0.94. What is the ratio of the Cereal Production (hectares) in Slovak Republic in 1998 to that in 2001?
Your answer should be very brief. 1.03. What is the ratio of the Cereal Production (hectares) of World in 1998 to that in 2002?
Offer a very short reply. 1.03. What is the ratio of the Cereal Production (hectares) in Saudi Arabia in 1998 to that in 2002?
Offer a terse response. 0.88. What is the ratio of the Cereal Production (hectares) in Slovak Republic in 1998 to that in 2002?
Provide a succinct answer. 1.05. What is the ratio of the Cereal Production (hectares) in World in 1998 to that in 2003?
Your answer should be compact. 1.01. What is the ratio of the Cereal Production (hectares) in Saudi Arabia in 1998 to that in 2003?
Ensure brevity in your answer.  0.89. What is the ratio of the Cereal Production (hectares) of Slovak Republic in 1998 to that in 2003?
Your response must be concise. 1.08. What is the ratio of the Cereal Production (hectares) in World in 1999 to that in 2000?
Offer a very short reply. 1. What is the ratio of the Cereal Production (hectares) of Saudi Arabia in 1999 to that in 2000?
Ensure brevity in your answer.  1.11. What is the ratio of the Cereal Production (hectares) in Slovak Republic in 1999 to that in 2000?
Make the answer very short. 0.9. What is the ratio of the Cereal Production (hectares) in World in 1999 to that in 2001?
Your answer should be compact. 1. What is the ratio of the Cereal Production (hectares) in Saudi Arabia in 1999 to that in 2001?
Your answer should be compact. 1.04. What is the ratio of the Cereal Production (hectares) in Slovak Republic in 1999 to that in 2001?
Offer a terse response. 0.88. What is the ratio of the Cereal Production (hectares) of World in 1999 to that in 2002?
Offer a terse response. 1.02. What is the ratio of the Cereal Production (hectares) of Saudi Arabia in 1999 to that in 2002?
Provide a short and direct response. 0.97. What is the ratio of the Cereal Production (hectares) in Slovak Republic in 1999 to that in 2002?
Make the answer very short. 0.89. What is the ratio of the Cereal Production (hectares) in World in 1999 to that in 2003?
Offer a terse response. 1. What is the ratio of the Cereal Production (hectares) of Saudi Arabia in 1999 to that in 2003?
Ensure brevity in your answer.  0.98. What is the ratio of the Cereal Production (hectares) of Slovak Republic in 1999 to that in 2003?
Your response must be concise. 0.92. What is the ratio of the Cereal Production (hectares) in Saudi Arabia in 2000 to that in 2001?
Keep it short and to the point. 0.94. What is the ratio of the Cereal Production (hectares) in Slovak Republic in 2000 to that in 2001?
Provide a short and direct response. 0.97. What is the ratio of the Cereal Production (hectares) of World in 2000 to that in 2002?
Your answer should be very brief. 1.02. What is the ratio of the Cereal Production (hectares) of Saudi Arabia in 2000 to that in 2002?
Provide a short and direct response. 0.87. What is the ratio of the Cereal Production (hectares) in Slovak Republic in 2000 to that in 2002?
Give a very brief answer. 0.99. What is the ratio of the Cereal Production (hectares) in World in 2000 to that in 2003?
Offer a very short reply. 1. What is the ratio of the Cereal Production (hectares) of Saudi Arabia in 2000 to that in 2003?
Ensure brevity in your answer.  0.88. What is the ratio of the Cereal Production (hectares) of Slovak Republic in 2000 to that in 2003?
Provide a short and direct response. 1.02. What is the ratio of the Cereal Production (hectares) in World in 2001 to that in 2002?
Provide a short and direct response. 1.02. What is the ratio of the Cereal Production (hectares) in Saudi Arabia in 2001 to that in 2002?
Keep it short and to the point. 0.94. What is the ratio of the Cereal Production (hectares) of Slovak Republic in 2001 to that in 2002?
Your response must be concise. 1.02. What is the ratio of the Cereal Production (hectares) in Saudi Arabia in 2001 to that in 2003?
Provide a short and direct response. 0.95. What is the ratio of the Cereal Production (hectares) in Slovak Republic in 2001 to that in 2003?
Provide a succinct answer. 1.05. What is the ratio of the Cereal Production (hectares) of World in 2002 to that in 2003?
Offer a terse response. 0.98. What is the ratio of the Cereal Production (hectares) in Saudi Arabia in 2002 to that in 2003?
Provide a succinct answer. 1.01. What is the ratio of the Cereal Production (hectares) in Slovak Republic in 2002 to that in 2003?
Offer a terse response. 1.03. What is the difference between the highest and the second highest Cereal Production (hectares) in World?
Ensure brevity in your answer.  3.68e+06. What is the difference between the highest and the second highest Cereal Production (hectares) of Saudi Arabia?
Offer a terse response. 7498. What is the difference between the highest and the second highest Cereal Production (hectares) of Slovak Republic?
Your answer should be very brief. 9363. What is the difference between the highest and the lowest Cereal Production (hectares) in World?
Give a very brief answer. 4.29e+07. What is the difference between the highest and the lowest Cereal Production (hectares) in Saudi Arabia?
Make the answer very short. 1.42e+05. What is the difference between the highest and the lowest Cereal Production (hectares) of Slovak Republic?
Offer a terse response. 1.26e+05. 